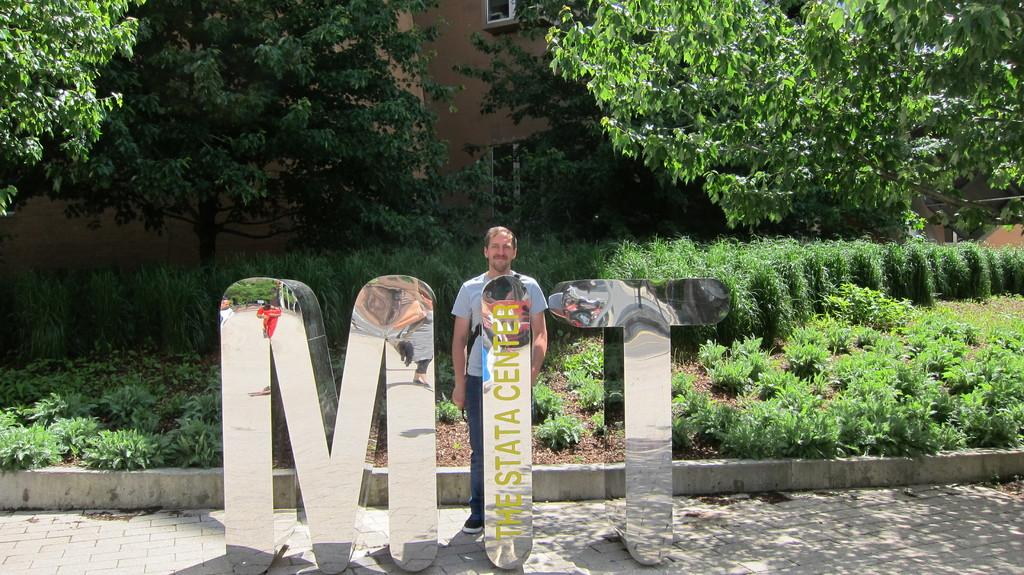What is the person in the image standing near? The person is standing near a name board in the image. How is the name board positioned in the image? The name board is placed on the ground. What can be seen in the background of the image? There are plants, trees, and a building in the background of the image. Is the person in the image crying or showing any signs of hate? There is no indication in the image that the person is crying or showing any signs of hate. 